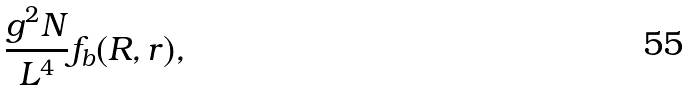Convert formula to latex. <formula><loc_0><loc_0><loc_500><loc_500>\frac { g ^ { 2 } N } { L ^ { 4 } } f _ { b } ( R , r ) ,</formula> 